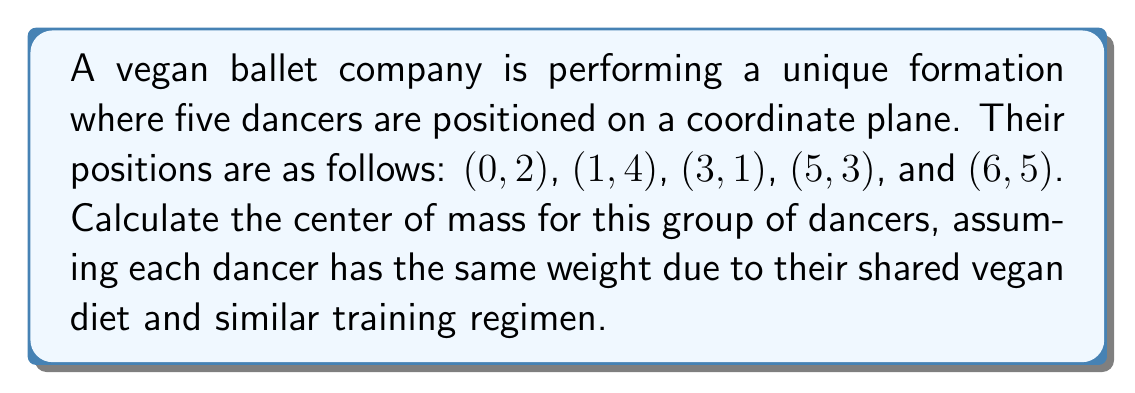Show me your answer to this math problem. To find the center of mass for a group of objects with equal weights, we need to calculate the average of their x-coordinates and y-coordinates separately.

Step 1: List all x-coordinates and y-coordinates.
x-coordinates: 0, 1, 3, 5, 6
y-coordinates: 2, 4, 1, 3, 5

Step 2: Calculate the average x-coordinate (x̄).
$$\bar{x} = \frac{0 + 1 + 3 + 5 + 6}{5} = \frac{15}{5} = 3$$

Step 3: Calculate the average y-coordinate (ȳ).
$$\bar{y} = \frac{2 + 4 + 1 + 3 + 5}{5} = \frac{15}{5} = 3$$

Step 4: The center of mass is the point $(\bar{x}, \bar{y})$.

Therefore, the center of mass for the group of dancers is $(3, 3)$.
Answer: $(3, 3)$ 